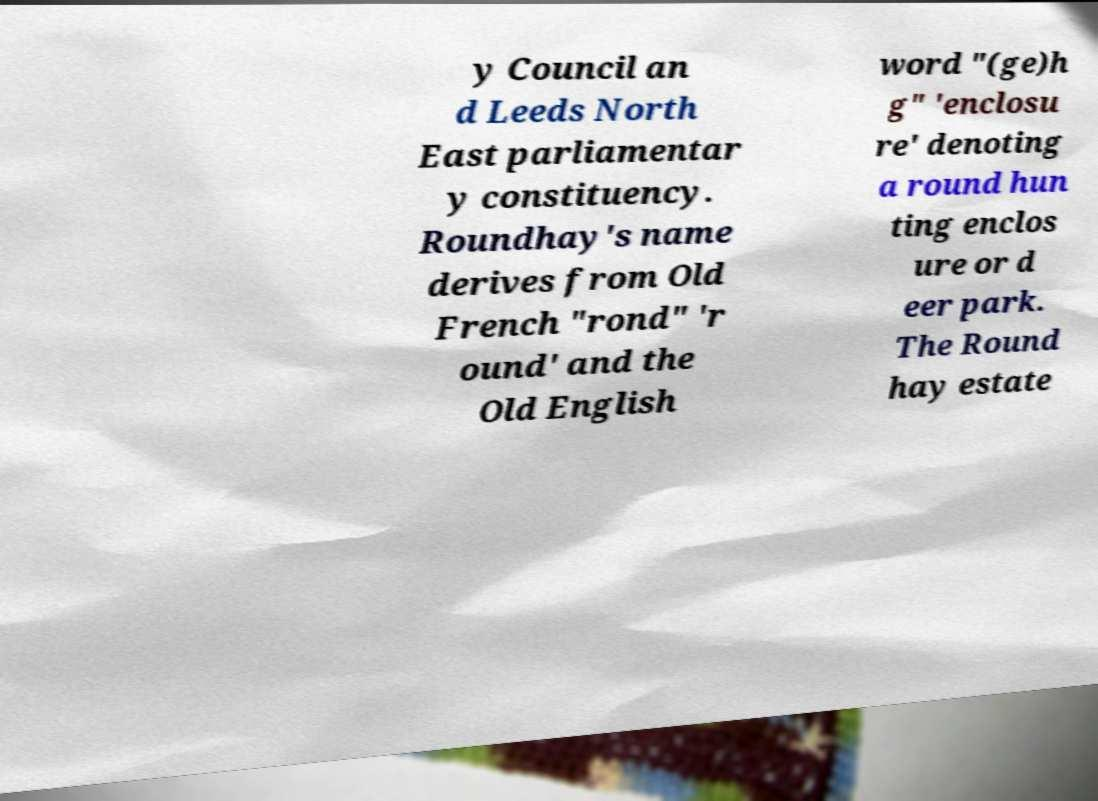For documentation purposes, I need the text within this image transcribed. Could you provide that? y Council an d Leeds North East parliamentar y constituency. Roundhay's name derives from Old French "rond" 'r ound' and the Old English word "(ge)h g" 'enclosu re' denoting a round hun ting enclos ure or d eer park. The Round hay estate 